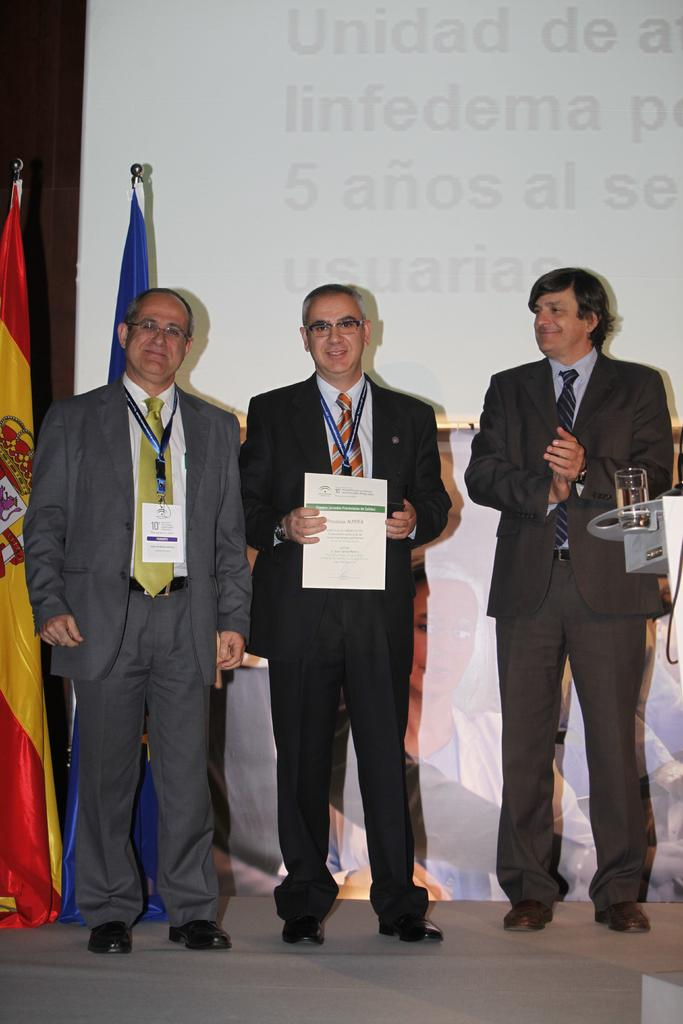How many people are present in the image? There are three people in the image. What is the middle person holding? The middle person is holding a certificate. Can you describe any other objects in the image? There is a glass visible in the image. What can be seen in the background of the image? There are flags in the background of the image. What type of instrument is being played by the person on the left in the image? There is no person playing an instrument in the image; only three people are present, and none of them are depicted playing an instrument. 